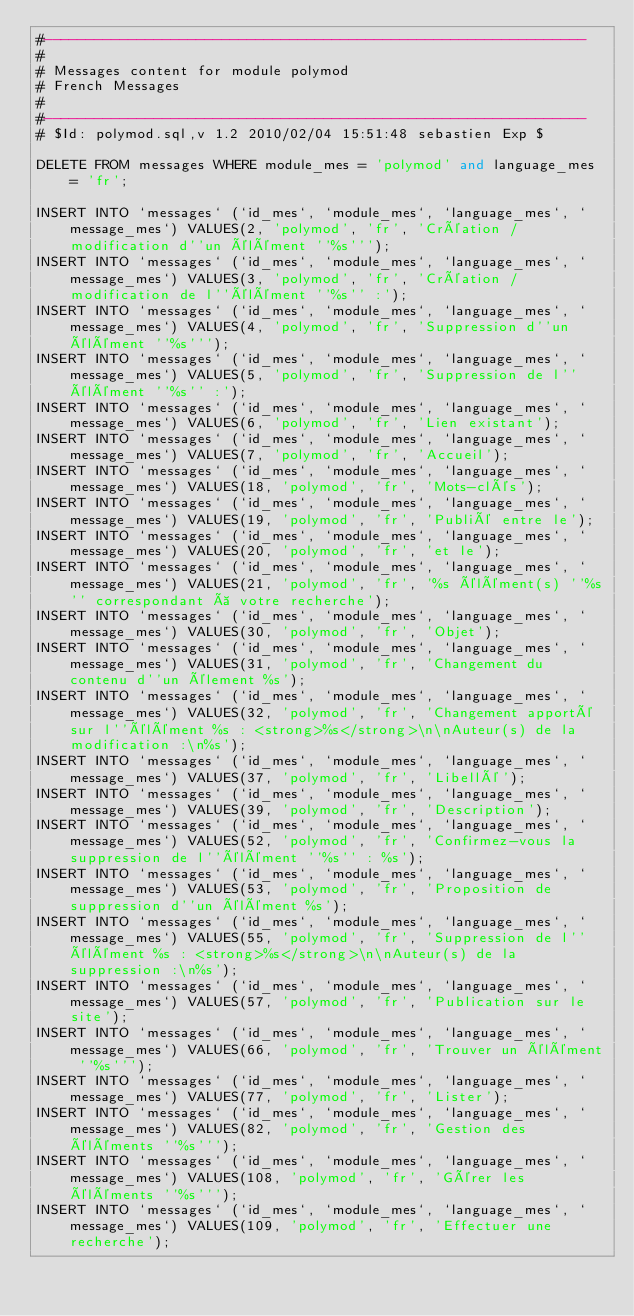<code> <loc_0><loc_0><loc_500><loc_500><_SQL_>#----------------------------------------------------------------
#
# Messages content for module polymod
# French Messages
#
#----------------------------------------------------------------
# $Id: polymod.sql,v 1.2 2010/02/04 15:51:48 sebastien Exp $

DELETE FROM messages WHERE module_mes = 'polymod' and language_mes = 'fr';

INSERT INTO `messages` (`id_mes`, `module_mes`, `language_mes`, `message_mes`) VALUES(2, 'polymod', 'fr', 'Création / modification d''un élément ''%s''');
INSERT INTO `messages` (`id_mes`, `module_mes`, `language_mes`, `message_mes`) VALUES(3, 'polymod', 'fr', 'Création / modification de l''élément ''%s'' :');
INSERT INTO `messages` (`id_mes`, `module_mes`, `language_mes`, `message_mes`) VALUES(4, 'polymod', 'fr', 'Suppression d''un élément ''%s''');
INSERT INTO `messages` (`id_mes`, `module_mes`, `language_mes`, `message_mes`) VALUES(5, 'polymod', 'fr', 'Suppression de l''élément ''%s'' :');
INSERT INTO `messages` (`id_mes`, `module_mes`, `language_mes`, `message_mes`) VALUES(6, 'polymod', 'fr', 'Lien existant');
INSERT INTO `messages` (`id_mes`, `module_mes`, `language_mes`, `message_mes`) VALUES(7, 'polymod', 'fr', 'Accueil');
INSERT INTO `messages` (`id_mes`, `module_mes`, `language_mes`, `message_mes`) VALUES(18, 'polymod', 'fr', 'Mots-clés');
INSERT INTO `messages` (`id_mes`, `module_mes`, `language_mes`, `message_mes`) VALUES(19, 'polymod', 'fr', 'Publié entre le');
INSERT INTO `messages` (`id_mes`, `module_mes`, `language_mes`, `message_mes`) VALUES(20, 'polymod', 'fr', 'et le');
INSERT INTO `messages` (`id_mes`, `module_mes`, `language_mes`, `message_mes`) VALUES(21, 'polymod', 'fr', '%s élément(s) ''%s'' correspondant à votre recherche');
INSERT INTO `messages` (`id_mes`, `module_mes`, `language_mes`, `message_mes`) VALUES(30, 'polymod', 'fr', 'Objet');
INSERT INTO `messages` (`id_mes`, `module_mes`, `language_mes`, `message_mes`) VALUES(31, 'polymod', 'fr', 'Changement du contenu d''un élement %s');
INSERT INTO `messages` (`id_mes`, `module_mes`, `language_mes`, `message_mes`) VALUES(32, 'polymod', 'fr', 'Changement apporté sur l''élément %s : <strong>%s</strong>\n\nAuteur(s) de la modification :\n%s');
INSERT INTO `messages` (`id_mes`, `module_mes`, `language_mes`, `message_mes`) VALUES(37, 'polymod', 'fr', 'Libellé');
INSERT INTO `messages` (`id_mes`, `module_mes`, `language_mes`, `message_mes`) VALUES(39, 'polymod', 'fr', 'Description');
INSERT INTO `messages` (`id_mes`, `module_mes`, `language_mes`, `message_mes`) VALUES(52, 'polymod', 'fr', 'Confirmez-vous la suppression de l''élément ''%s'' : %s');
INSERT INTO `messages` (`id_mes`, `module_mes`, `language_mes`, `message_mes`) VALUES(53, 'polymod', 'fr', 'Proposition de suppression d''un élément %s');
INSERT INTO `messages` (`id_mes`, `module_mes`, `language_mes`, `message_mes`) VALUES(55, 'polymod', 'fr', 'Suppression de l''élément %s : <strong>%s</strong>\n\nAuteur(s) de la suppression :\n%s');
INSERT INTO `messages` (`id_mes`, `module_mes`, `language_mes`, `message_mes`) VALUES(57, 'polymod', 'fr', 'Publication sur le site');
INSERT INTO `messages` (`id_mes`, `module_mes`, `language_mes`, `message_mes`) VALUES(66, 'polymod', 'fr', 'Trouver un élément ''%s''');
INSERT INTO `messages` (`id_mes`, `module_mes`, `language_mes`, `message_mes`) VALUES(77, 'polymod', 'fr', 'Lister');
INSERT INTO `messages` (`id_mes`, `module_mes`, `language_mes`, `message_mes`) VALUES(82, 'polymod', 'fr', 'Gestion des éléments ''%s''');
INSERT INTO `messages` (`id_mes`, `module_mes`, `language_mes`, `message_mes`) VALUES(108, 'polymod', 'fr', 'Gérer les éléments ''%s''');
INSERT INTO `messages` (`id_mes`, `module_mes`, `language_mes`, `message_mes`) VALUES(109, 'polymod', 'fr', 'Effectuer une recherche');</code> 